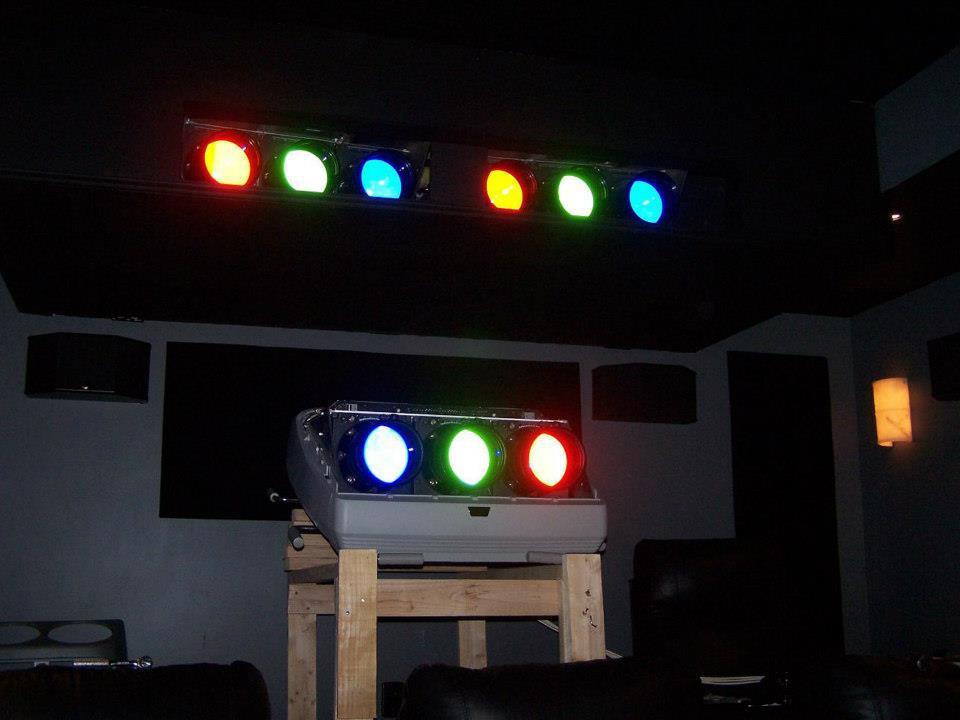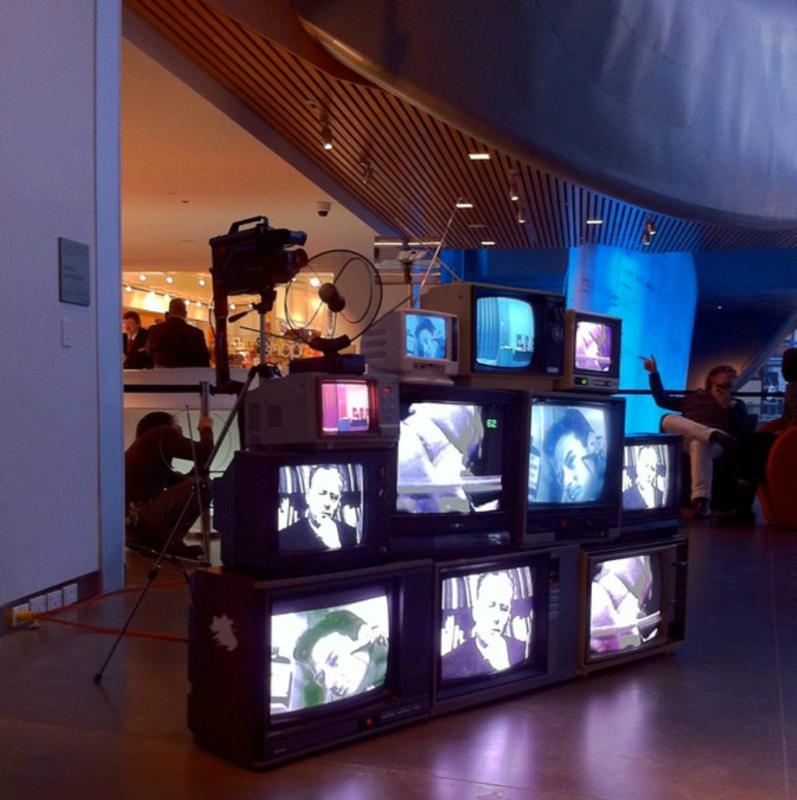The first image is the image on the left, the second image is the image on the right. For the images displayed, is the sentence "One image shows an interior with an exposed beam ceiling and multiple stacks of televisions with pictures on their screens stacked along the lefthand wall." factually correct? Answer yes or no. No. 